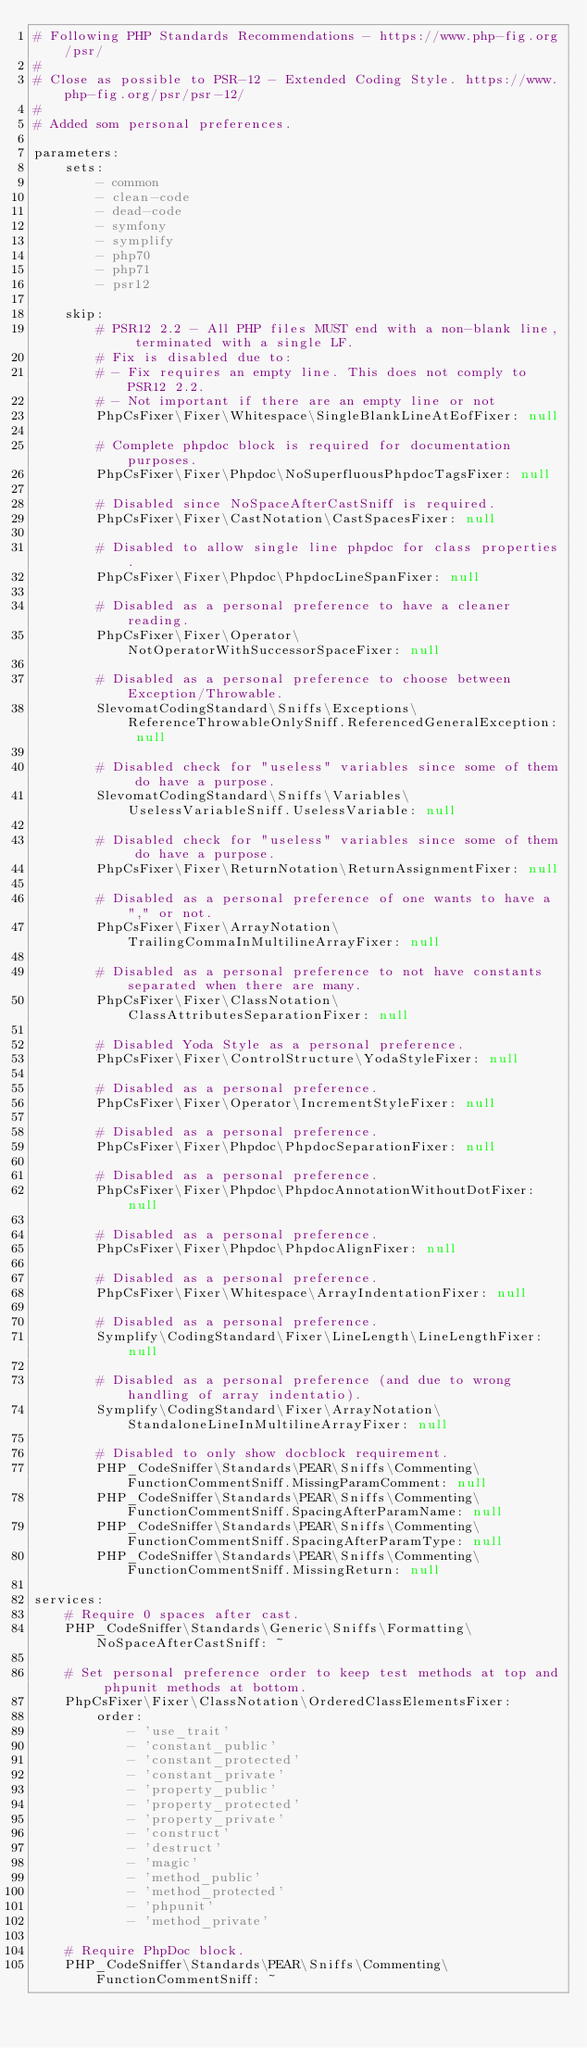<code> <loc_0><loc_0><loc_500><loc_500><_YAML_># Following PHP Standards Recommendations - https://www.php-fig.org/psr/
#
# Close as possible to PSR-12 - Extended Coding Style. https://www.php-fig.org/psr/psr-12/
#
# Added som personal preferences.

parameters:
    sets:
        - common
        - clean-code
        - dead-code
        - symfony
        - symplify
        - php70
        - php71
        - psr12

    skip:
        # PSR12 2.2 - All PHP files MUST end with a non-blank line, terminated with a single LF.
        # Fix is disabled due to:
        # - Fix requires an empty line. This does not comply to PSR12 2.2.
        # - Not important if there are an empty line or not
        PhpCsFixer\Fixer\Whitespace\SingleBlankLineAtEofFixer: null

        # Complete phpdoc block is required for documentation purposes.
        PhpCsFixer\Fixer\Phpdoc\NoSuperfluousPhpdocTagsFixer: null

        # Disabled since NoSpaceAfterCastSniff is required.
        PhpCsFixer\Fixer\CastNotation\CastSpacesFixer: null

        # Disabled to allow single line phpdoc for class properties.
        PhpCsFixer\Fixer\Phpdoc\PhpdocLineSpanFixer: null

        # Disabled as a personal preference to have a cleaner reading.
        PhpCsFixer\Fixer\Operator\NotOperatorWithSuccessorSpaceFixer: null

        # Disabled as a personal preference to choose between Exception/Throwable.
        SlevomatCodingStandard\Sniffs\Exceptions\ReferenceThrowableOnlySniff.ReferencedGeneralException: null

        # Disabled check for "useless" variables since some of them do have a purpose.
        SlevomatCodingStandard\Sniffs\Variables\UselessVariableSniff.UselessVariable: null

        # Disabled check for "useless" variables since some of them do have a purpose.
        PhpCsFixer\Fixer\ReturnNotation\ReturnAssignmentFixer: null

        # Disabled as a personal preference of one wants to have a "," or not.
        PhpCsFixer\Fixer\ArrayNotation\TrailingCommaInMultilineArrayFixer: null

        # Disabled as a personal preference to not have constants separated when there are many.
        PhpCsFixer\Fixer\ClassNotation\ClassAttributesSeparationFixer: null

        # Disabled Yoda Style as a personal preference.
        PhpCsFixer\Fixer\ControlStructure\YodaStyleFixer: null

        # Disabled as a personal preference.
        PhpCsFixer\Fixer\Operator\IncrementStyleFixer: null

        # Disabled as a personal preference.
        PhpCsFixer\Fixer\Phpdoc\PhpdocSeparationFixer: null

        # Disabled as a personal preference.
        PhpCsFixer\Fixer\Phpdoc\PhpdocAnnotationWithoutDotFixer: null

        # Disabled as a personal preference.
        PhpCsFixer\Fixer\Phpdoc\PhpdocAlignFixer: null

        # Disabled as a personal preference.
        PhpCsFixer\Fixer\Whitespace\ArrayIndentationFixer: null

        # Disabled as a personal preference.
        Symplify\CodingStandard\Fixer\LineLength\LineLengthFixer: null

        # Disabled as a personal preference (and due to wrong handling of array indentatio).
        Symplify\CodingStandard\Fixer\ArrayNotation\StandaloneLineInMultilineArrayFixer: null

        # Disabled to only show docblock requirement.
        PHP_CodeSniffer\Standards\PEAR\Sniffs\Commenting\FunctionCommentSniff.MissingParamComment: null
        PHP_CodeSniffer\Standards\PEAR\Sniffs\Commenting\FunctionCommentSniff.SpacingAfterParamName: null
        PHP_CodeSniffer\Standards\PEAR\Sniffs\Commenting\FunctionCommentSniff.SpacingAfterParamType: null
        PHP_CodeSniffer\Standards\PEAR\Sniffs\Commenting\FunctionCommentSniff.MissingReturn: null

services:
    # Require 0 spaces after cast.
    PHP_CodeSniffer\Standards\Generic\Sniffs\Formatting\NoSpaceAfterCastSniff: ~

    # Set personal preference order to keep test methods at top and phpunit methods at bottom.
    PhpCsFixer\Fixer\ClassNotation\OrderedClassElementsFixer:
        order:
            - 'use_trait'
            - 'constant_public'
            - 'constant_protected'
            - 'constant_private'
            - 'property_public'
            - 'property_protected'
            - 'property_private'
            - 'construct'
            - 'destruct'
            - 'magic'
            - 'method_public'
            - 'method_protected'
            - 'phpunit'
            - 'method_private'

    # Require PhpDoc block.
    PHP_CodeSniffer\Standards\PEAR\Sniffs\Commenting\FunctionCommentSniff: ~
</code> 